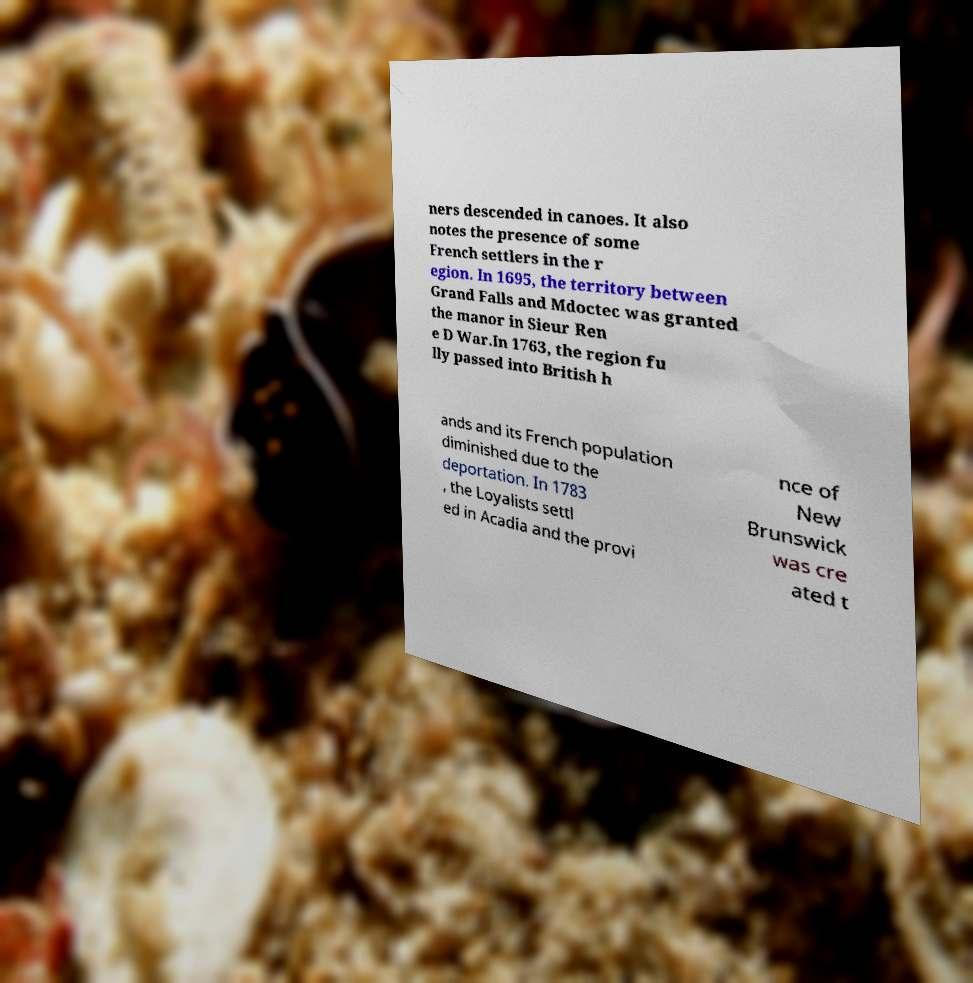Please read and relay the text visible in this image. What does it say? ners descended in canoes. It also notes the presence of some French settlers in the r egion. In 1695, the territory between Grand Falls and Mdoctec was granted the manor in Sieur Ren e D War.In 1763, the region fu lly passed into British h ands and its French population diminished due to the deportation. In 1783 , the Loyalists settl ed in Acadia and the provi nce of New Brunswick was cre ated t 